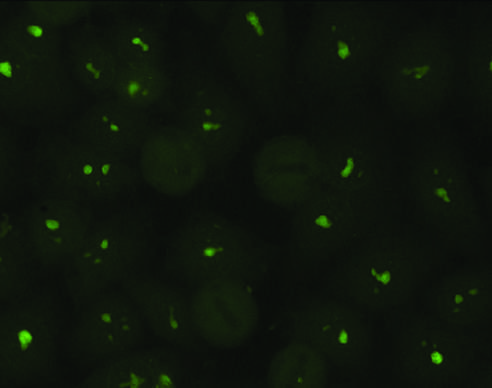s an infarct in the brain typical of antibodies against nucleolar proteins?
Answer the question using a single word or phrase. No 